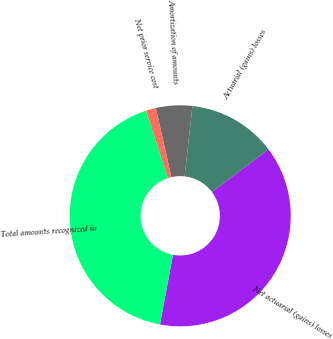Convert chart to OTSL. <chart><loc_0><loc_0><loc_500><loc_500><pie_chart><fcel>Net actuarial (gains) losses<fcel>Actuarial (gains) losses<fcel>Amortization of amounts<fcel>Net prior service cost<fcel>Total amounts recognized in<nl><fcel>38.22%<fcel>12.95%<fcel>5.31%<fcel>1.49%<fcel>42.04%<nl></chart> 